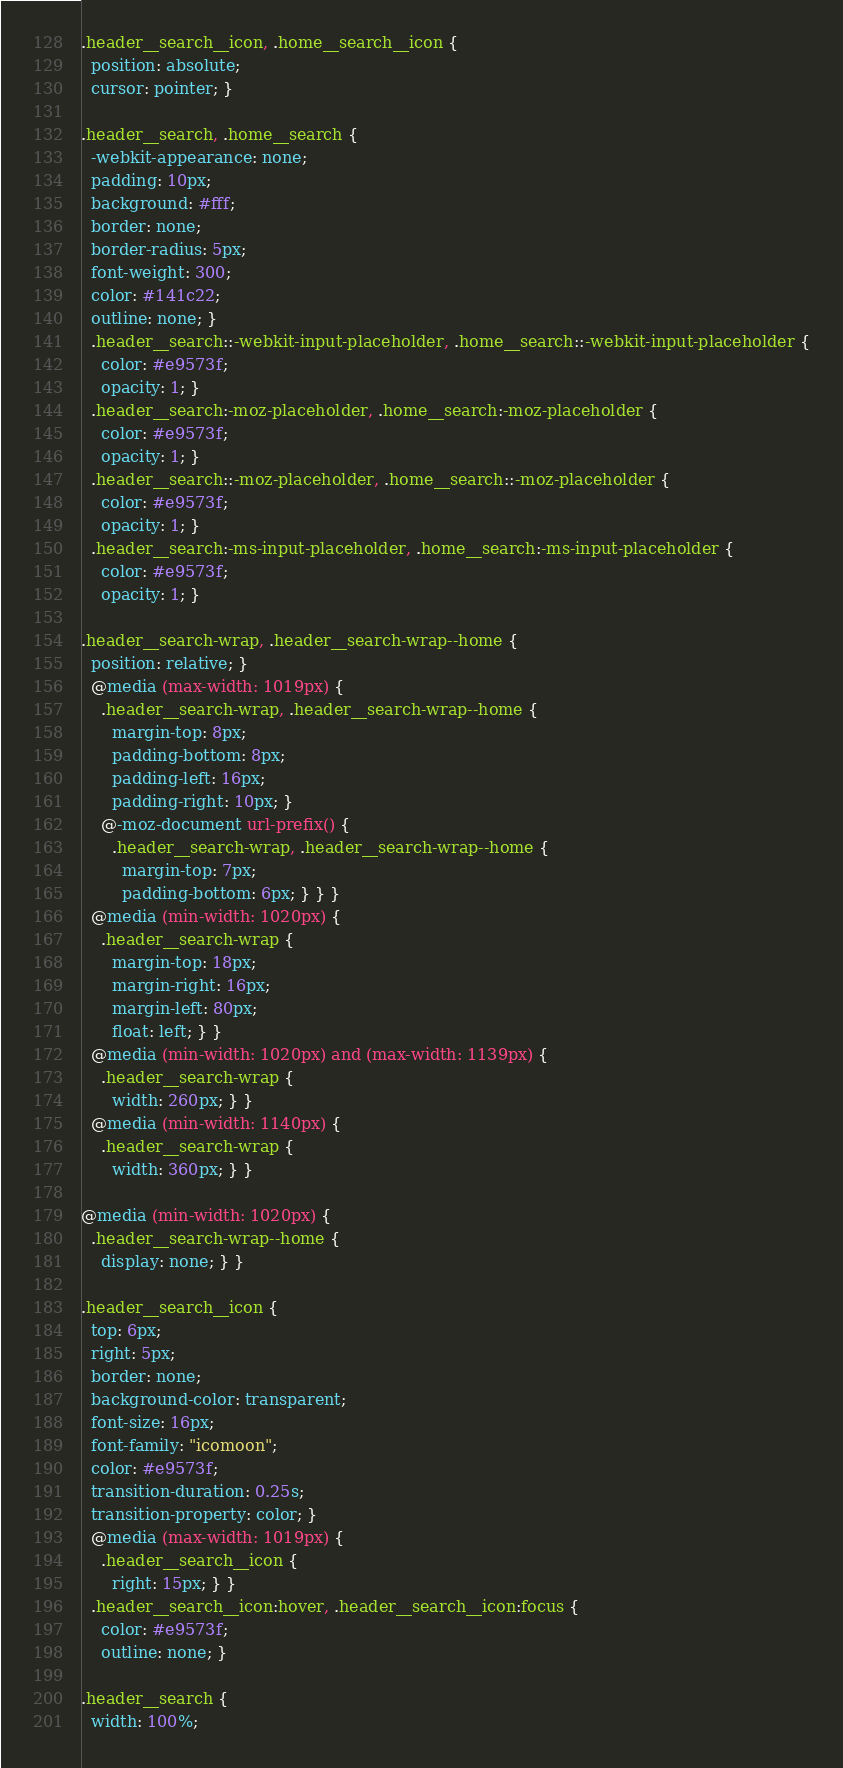Convert code to text. <code><loc_0><loc_0><loc_500><loc_500><_CSS_>.header__search__icon, .home__search__icon {
  position: absolute;
  cursor: pointer; }

.header__search, .home__search {
  -webkit-appearance: none;
  padding: 10px;
  background: #fff;
  border: none;
  border-radius: 5px;
  font-weight: 300;
  color: #141c22;
  outline: none; }
  .header__search::-webkit-input-placeholder, .home__search::-webkit-input-placeholder {
    color: #e9573f;
    opacity: 1; }
  .header__search:-moz-placeholder, .home__search:-moz-placeholder {
    color: #e9573f;
    opacity: 1; }
  .header__search::-moz-placeholder, .home__search::-moz-placeholder {
    color: #e9573f;
    opacity: 1; }
  .header__search:-ms-input-placeholder, .home__search:-ms-input-placeholder {
    color: #e9573f;
    opacity: 1; }

.header__search-wrap, .header__search-wrap--home {
  position: relative; }
  @media (max-width: 1019px) {
    .header__search-wrap, .header__search-wrap--home {
      margin-top: 8px;
      padding-bottom: 8px;
      padding-left: 16px;
      padding-right: 10px; }
    @-moz-document url-prefix() {
      .header__search-wrap, .header__search-wrap--home {
        margin-top: 7px;
        padding-bottom: 6px; } } }
  @media (min-width: 1020px) {
    .header__search-wrap {
      margin-top: 18px;
      margin-right: 16px;
      margin-left: 80px;
      float: left; } }
  @media (min-width: 1020px) and (max-width: 1139px) {
    .header__search-wrap {
      width: 260px; } }
  @media (min-width: 1140px) {
    .header__search-wrap {
      width: 360px; } }

@media (min-width: 1020px) {
  .header__search-wrap--home {
    display: none; } }

.header__search__icon {
  top: 6px;
  right: 5px;
  border: none;
  background-color: transparent;
  font-size: 16px;
  font-family: "icomoon";
  color: #e9573f;
  transition-duration: 0.25s;
  transition-property: color; }
  @media (max-width: 1019px) {
    .header__search__icon {
      right: 15px; } }
  .header__search__icon:hover, .header__search__icon:focus {
    color: #e9573f;
    outline: none; }

.header__search {
  width: 100%;</code> 